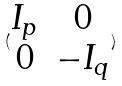Convert formula to latex. <formula><loc_0><loc_0><loc_500><loc_500>( \begin{matrix} I _ { p } & 0 \\ 0 & - I _ { q } \end{matrix} )</formula> 